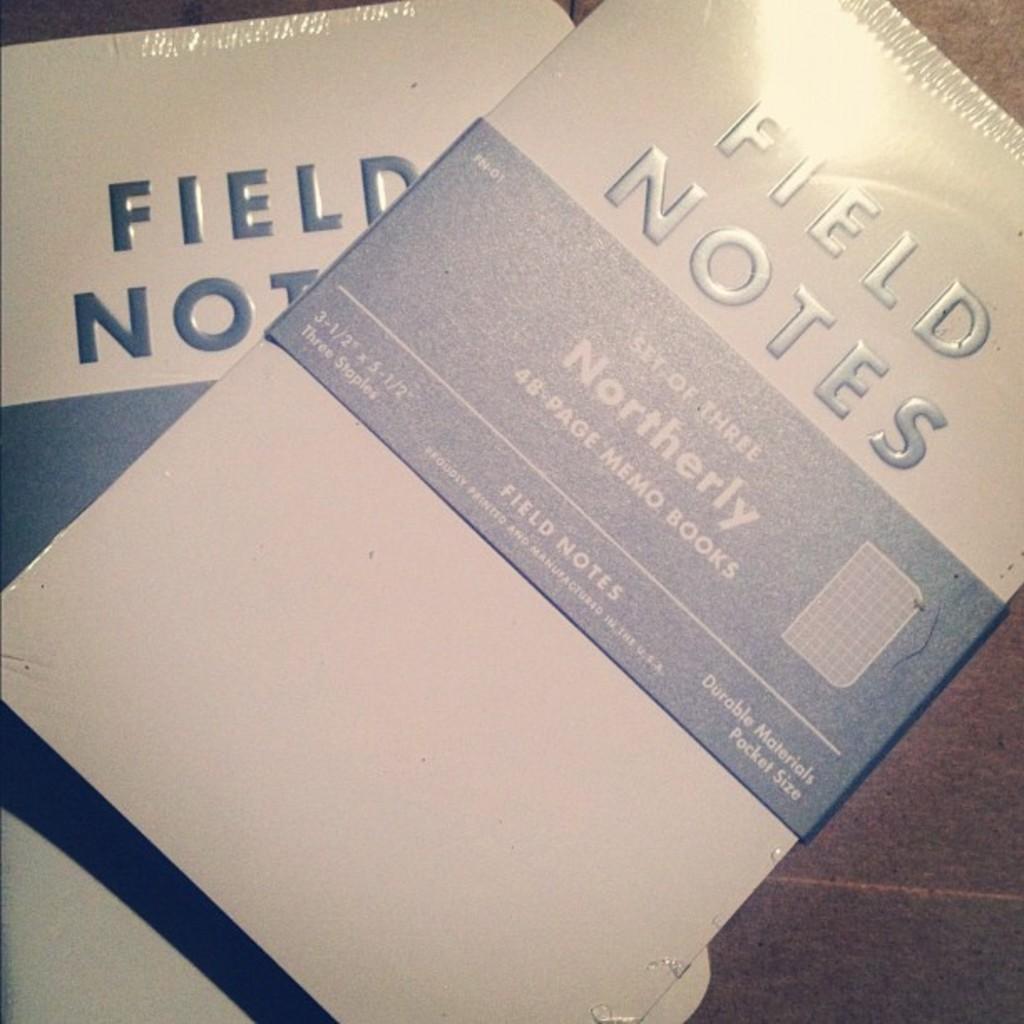What kind of notebook is this?
Provide a succinct answer. Field notes. What is the title of the book?
Your answer should be very brief. Field notes. 